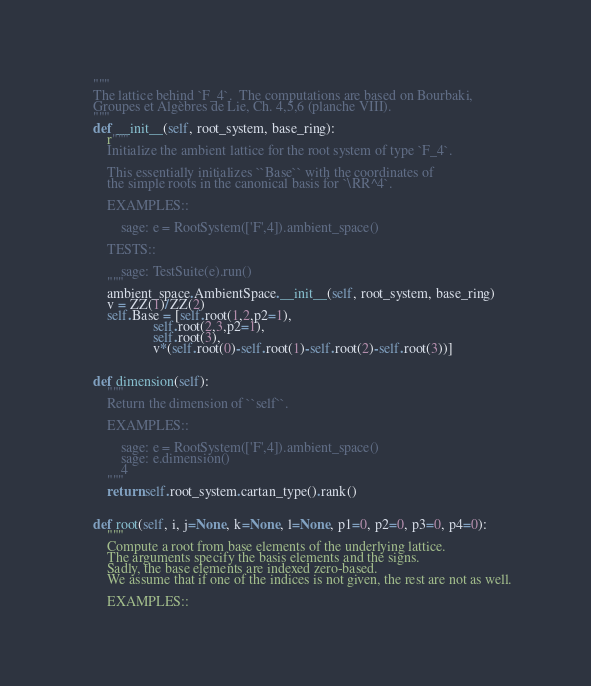<code> <loc_0><loc_0><loc_500><loc_500><_Python_>    """
    The lattice behind `F_4`.  The computations are based on Bourbaki,
    Groupes et Algèbres de Lie, Ch. 4,5,6 (planche VIII).
    """
    def __init__(self, root_system, base_ring):
        r"""
        Initialize the ambient lattice for the root system of type `F_4`.

        This essentially initializes ``Base`` with the coordinates of
        the simple roots in the canonical basis for `\RR^4`.

        EXAMPLES::

            sage: e = RootSystem(['F',4]).ambient_space()

        TESTS::

            sage: TestSuite(e).run()
        """
        ambient_space.AmbientSpace.__init__(self, root_system, base_ring)
        v = ZZ(1)/ZZ(2)
        self.Base = [self.root(1,2,p2=1),
                     self.root(2,3,p2=1),
                     self.root(3),
                     v*(self.root(0)-self.root(1)-self.root(2)-self.root(3))]


    def dimension(self):
        """
        Return the dimension of ``self``.

        EXAMPLES::

            sage: e = RootSystem(['F',4]).ambient_space()
            sage: e.dimension()
            4
        """
        return self.root_system.cartan_type().rank()


    def root(self, i, j=None, k=None, l=None, p1=0, p2=0, p3=0, p4=0):
        """
        Compute a root from base elements of the underlying lattice.
        The arguments specify the basis elements and the signs.
        Sadly, the base elements are indexed zero-based.
        We assume that if one of the indices is not given, the rest are not as well.

        EXAMPLES::
</code> 